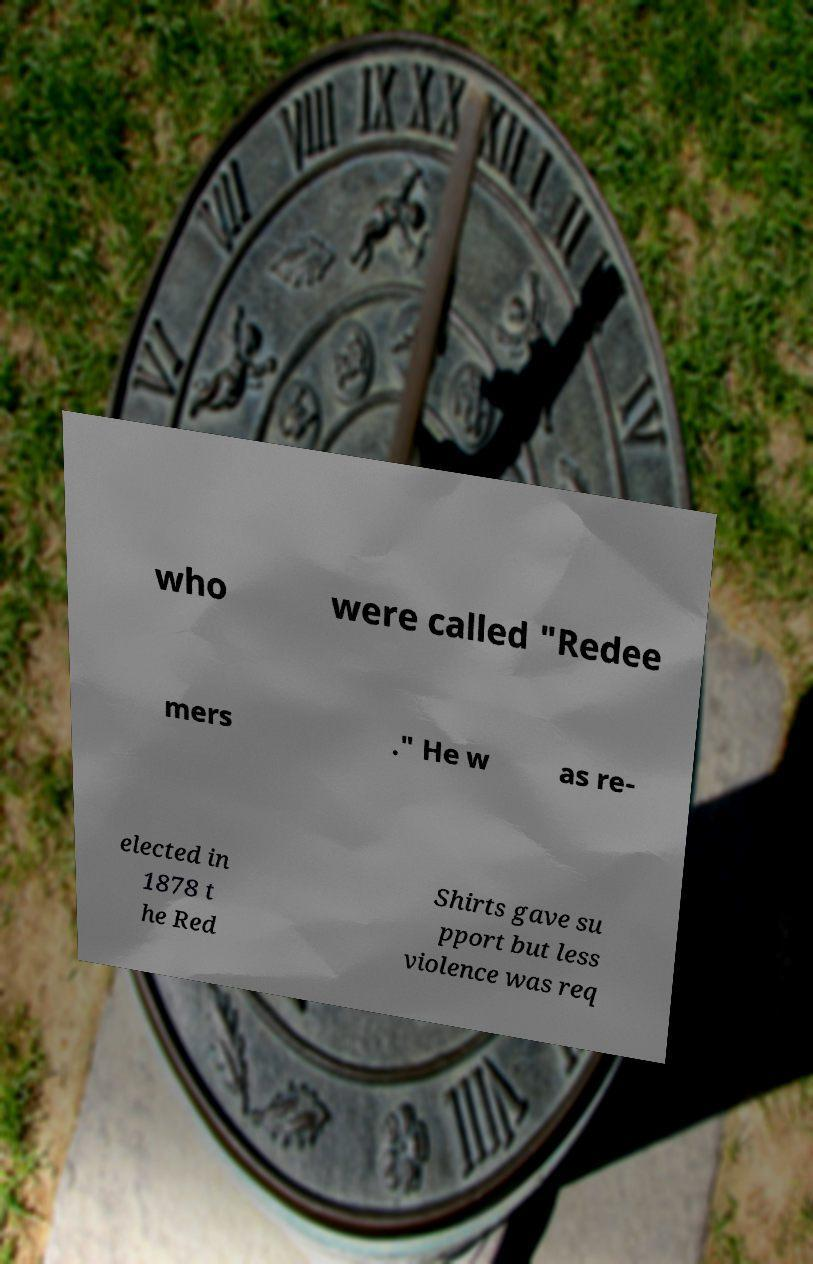Can you read and provide the text displayed in the image?This photo seems to have some interesting text. Can you extract and type it out for me? who were called "Redee mers ." He w as re- elected in 1878 t he Red Shirts gave su pport but less violence was req 